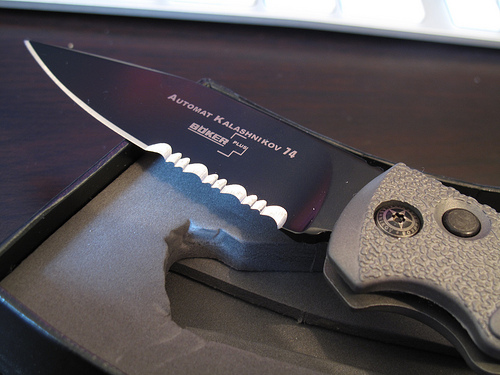<image>
Is there a knife behind the handle? No. The knife is not behind the handle. From this viewpoint, the knife appears to be positioned elsewhere in the scene. 